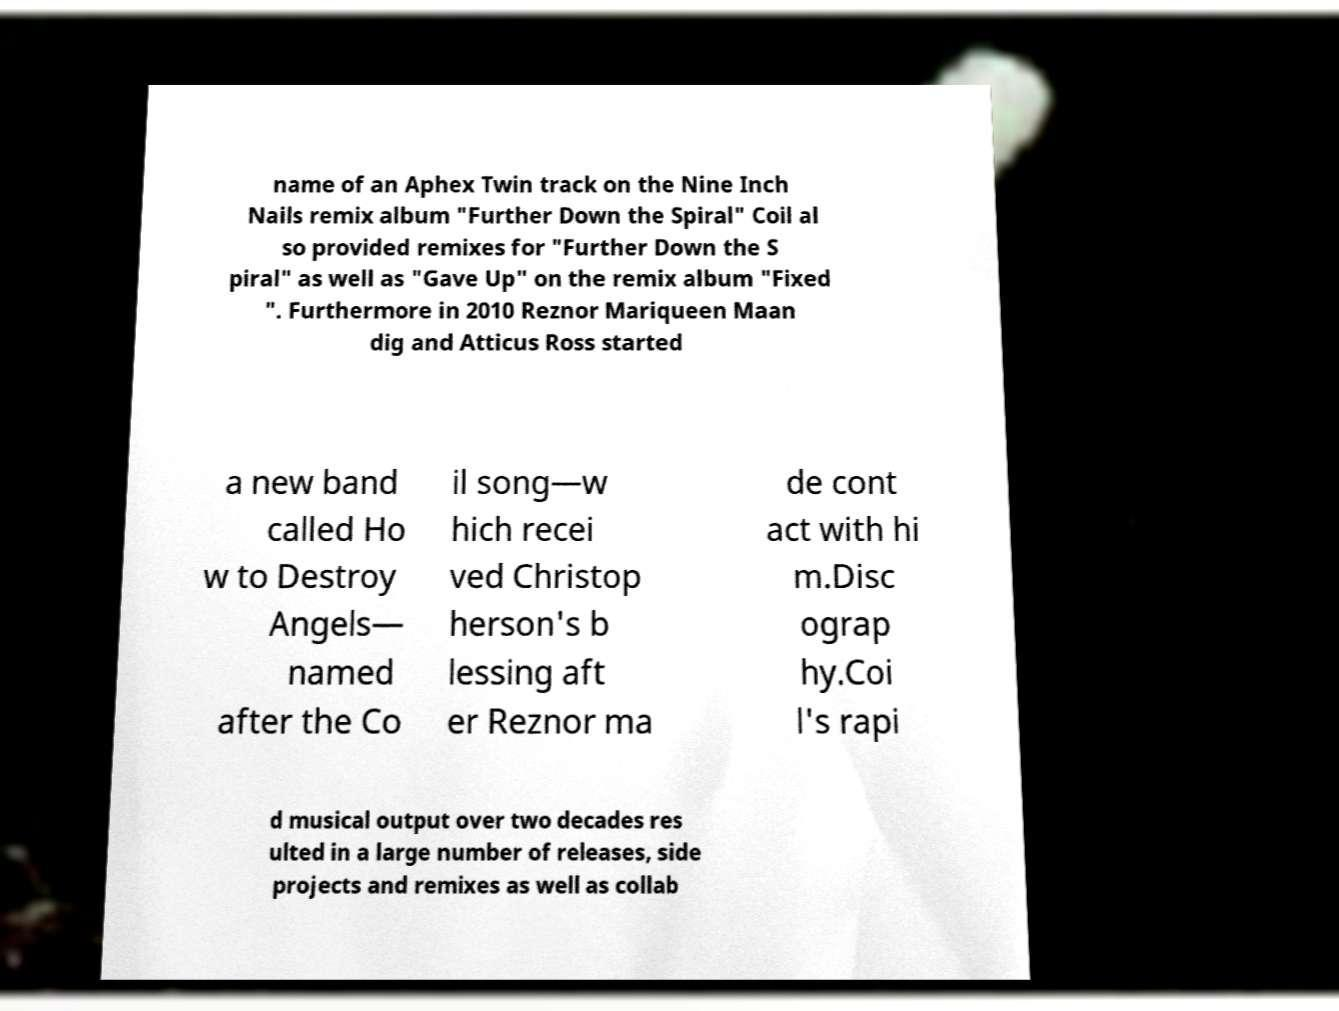Can you read and provide the text displayed in the image?This photo seems to have some interesting text. Can you extract and type it out for me? name of an Aphex Twin track on the Nine Inch Nails remix album "Further Down the Spiral" Coil al so provided remixes for "Further Down the S piral" as well as "Gave Up" on the remix album "Fixed ". Furthermore in 2010 Reznor Mariqueen Maan dig and Atticus Ross started a new band called Ho w to Destroy Angels— named after the Co il song—w hich recei ved Christop herson's b lessing aft er Reznor ma de cont act with hi m.Disc ograp hy.Coi l's rapi d musical output over two decades res ulted in a large number of releases, side projects and remixes as well as collab 